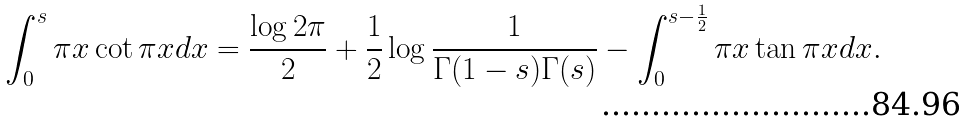<formula> <loc_0><loc_0><loc_500><loc_500>\int _ { 0 } ^ { s } \pi x \cot \pi x d x = \frac { \log 2 \pi } { 2 } + \frac { 1 } { 2 } \log \frac { 1 } { \Gamma ( 1 - s ) \Gamma ( s ) } - \int _ { 0 } ^ { s - \frac { 1 } { 2 } } \pi x \tan \pi x d x .</formula> 